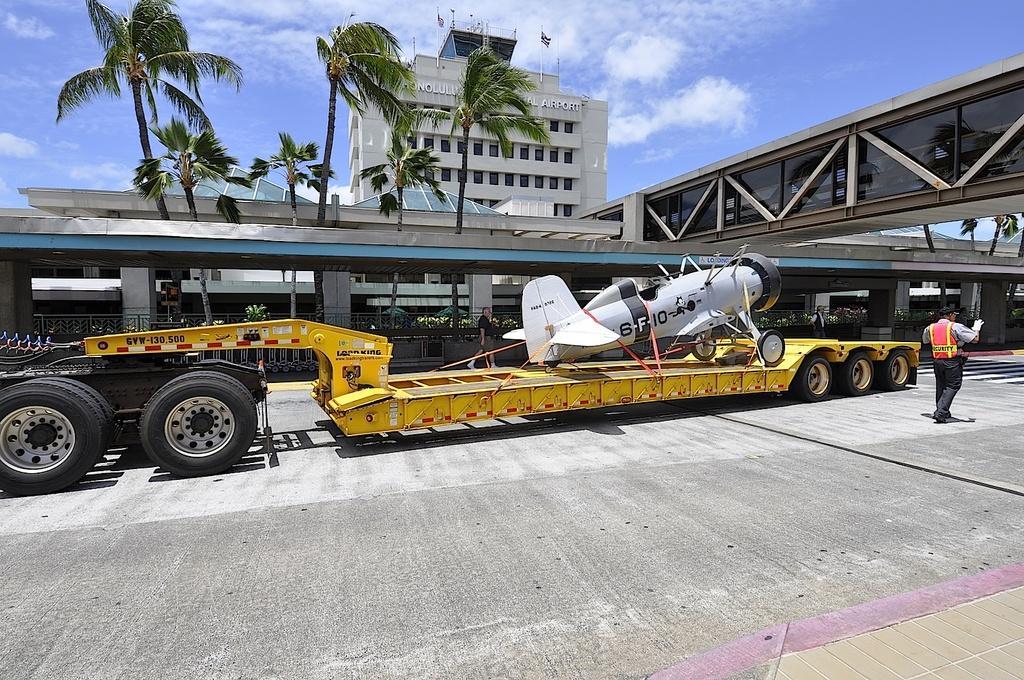Can you describe this image briefly? In this image there is a truck on that tuck there is a aircraft, on either side of the truck there are two men, in the background there is a shelter, above the shelter there is a bridge, behind the shelter there are trees, behind the trees there is a building and the sky. 